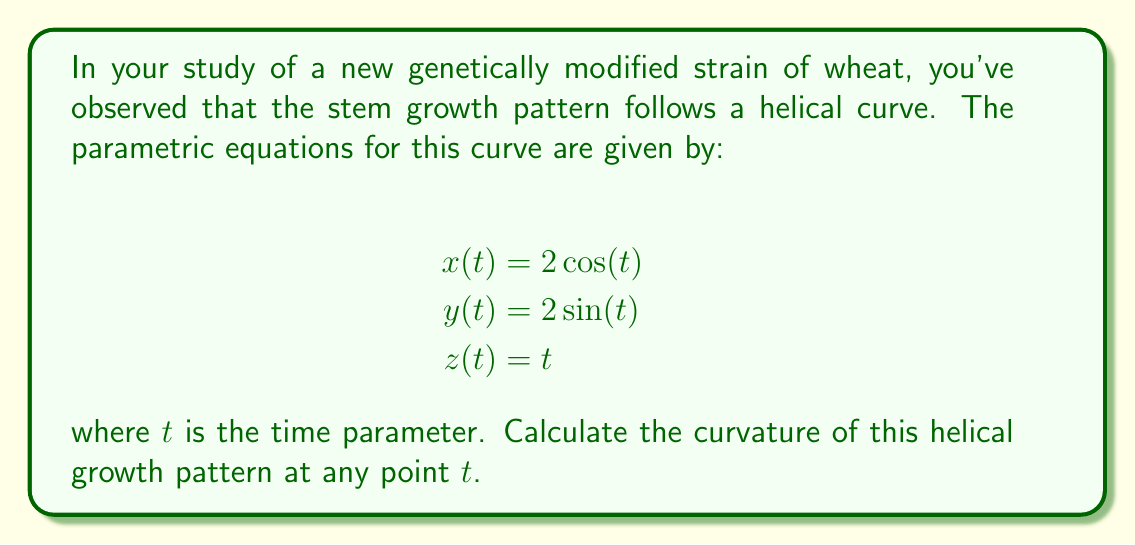Provide a solution to this math problem. To calculate the curvature of the helical growth pattern, we'll follow these steps:

1) First, we need to find the first and second derivatives of the position vector $\mathbf{r}(t) = (x(t), y(t), z(t))$:

   $\mathbf{r}(t) = (2\cos(t), 2\sin(t), t)$
   $\mathbf{r}'(t) = (-2\sin(t), 2\cos(t), 1)$
   $\mathbf{r}''(t) = (-2\cos(t), -2\sin(t), 0)$

2) The curvature $\kappa$ is given by the formula:

   $$\kappa = \frac{|\mathbf{r}'(t) \times \mathbf{r}''(t)|}{|\mathbf{r}'(t)|^3}$$

3) Let's calculate the cross product $\mathbf{r}'(t) \times \mathbf{r}''(t)$:

   $\mathbf{r}'(t) \times \mathbf{r}''(t) = \begin{vmatrix} 
   \mathbf{i} & \mathbf{j} & \mathbf{k} \\
   -2\sin(t) & 2\cos(t) & 1 \\
   -2\cos(t) & -2\sin(t) & 0
   \end{vmatrix}$

   $= (2\cos(t) \cdot 0 - 1 \cdot (-2\sin(t)))\mathbf{i} + ((-2\sin(t) \cdot 0 - 1 \cdot (-2\cos(t)))\mathbf{j} + (-2\sin(t) \cdot (-2\sin(t)) - 2\cos(t) \cdot 2\cos(t))\mathbf{k}$

   $= 2\sin(t)\mathbf{i} + 2\cos(t)\mathbf{j} + (-4)\mathbf{k}$

4) The magnitude of this cross product is:

   $|\mathbf{r}'(t) \times \mathbf{r}''(t)| = \sqrt{4\sin^2(t) + 4\cos^2(t) + 16} = \sqrt{4 + 16} = \sqrt{20} = 2\sqrt{5}$

5) Now, let's calculate $|\mathbf{r}'(t)|$:

   $|\mathbf{r}'(t)| = \sqrt{(-2\sin(t))^2 + (2\cos(t))^2 + 1^2} = \sqrt{4\sin^2(t) + 4\cos^2(t) + 1} = \sqrt{5}$

6) Therefore, $|\mathbf{r}'(t)|^3 = (\sqrt{5})^3 = 5\sqrt{5}$

7) Substituting these values into the curvature formula:

   $$\kappa = \frac{|\mathbf{r}'(t) \times \mathbf{r}''(t)|}{|\mathbf{r}'(t)|^3} = \frac{2\sqrt{5}}{5\sqrt{5}} = \frac{2}{5}$$
Answer: $\frac{2}{5}$ 